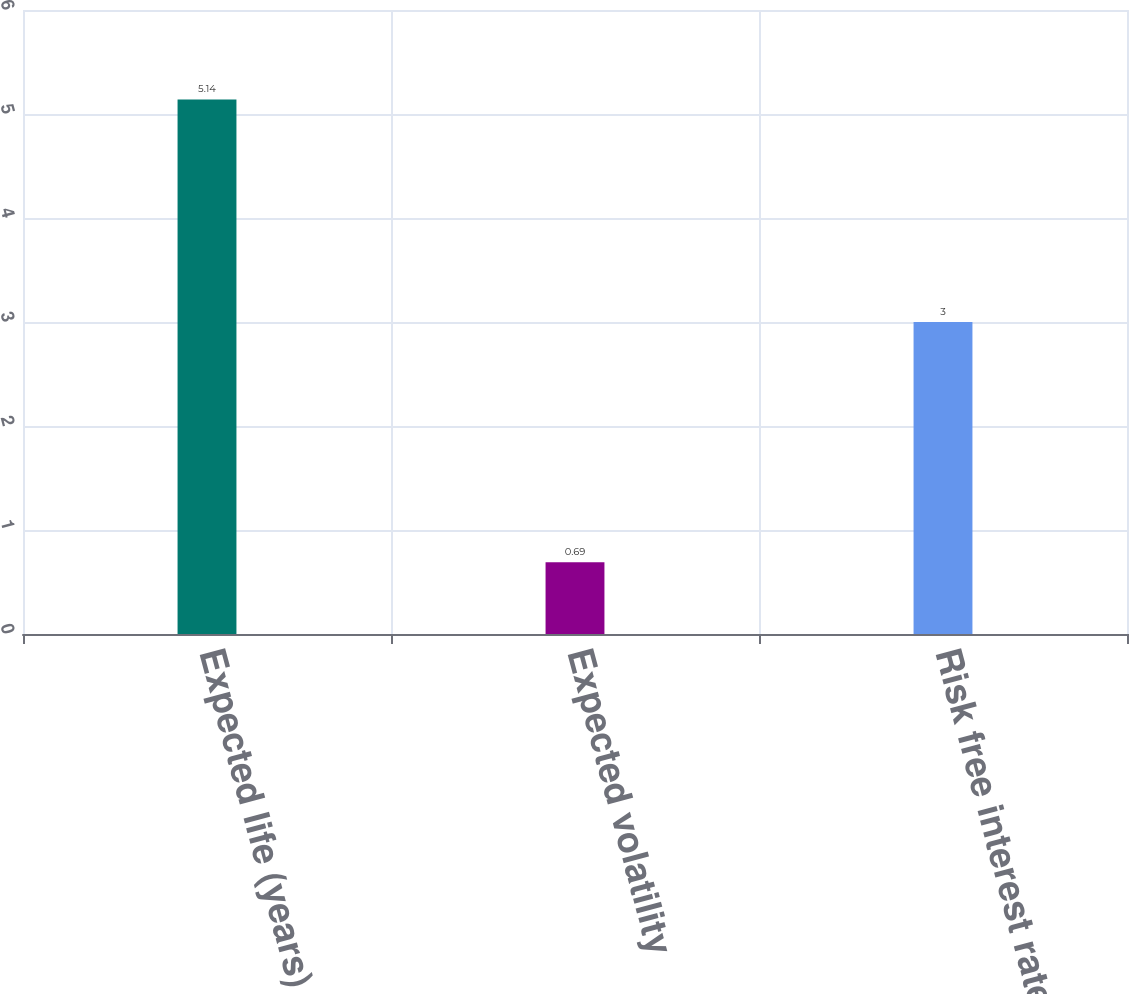Convert chart. <chart><loc_0><loc_0><loc_500><loc_500><bar_chart><fcel>Expected life (years)<fcel>Expected volatility<fcel>Risk free interest rate<nl><fcel>5.14<fcel>0.69<fcel>3<nl></chart> 